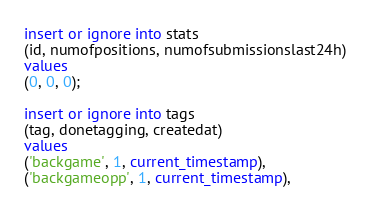<code> <loc_0><loc_0><loc_500><loc_500><_SQL_>insert or ignore into stats
(id, numofpositions, numofsubmissionslast24h)
values
(0, 0, 0);

insert or ignore into tags
(tag, donetagging, createdat)
values
('backgame', 1, current_timestamp),
('backgameopp', 1, current_timestamp),</code> 